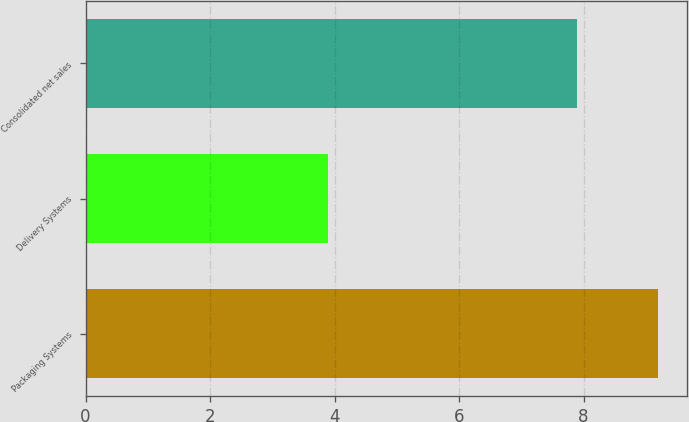Convert chart. <chart><loc_0><loc_0><loc_500><loc_500><bar_chart><fcel>Packaging Systems<fcel>Delivery Systems<fcel>Consolidated net sales<nl><fcel>9.2<fcel>3.9<fcel>7.9<nl></chart> 